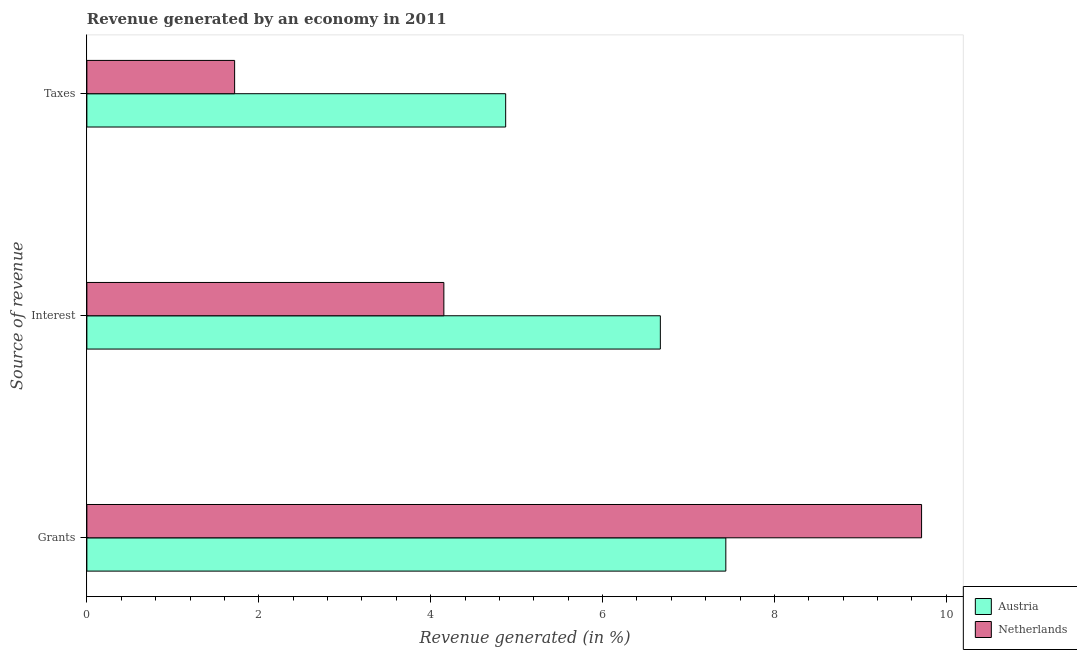Are the number of bars per tick equal to the number of legend labels?
Offer a very short reply. Yes. What is the label of the 1st group of bars from the top?
Your response must be concise. Taxes. What is the percentage of revenue generated by taxes in Austria?
Offer a very short reply. 4.87. Across all countries, what is the maximum percentage of revenue generated by taxes?
Offer a terse response. 4.87. Across all countries, what is the minimum percentage of revenue generated by taxes?
Provide a succinct answer. 1.72. In which country was the percentage of revenue generated by taxes minimum?
Provide a short and direct response. Netherlands. What is the total percentage of revenue generated by taxes in the graph?
Your answer should be compact. 6.59. What is the difference between the percentage of revenue generated by interest in Austria and that in Netherlands?
Provide a short and direct response. 2.52. What is the difference between the percentage of revenue generated by grants in Austria and the percentage of revenue generated by taxes in Netherlands?
Your answer should be very brief. 5.72. What is the average percentage of revenue generated by grants per country?
Give a very brief answer. 8.57. What is the difference between the percentage of revenue generated by grants and percentage of revenue generated by taxes in Netherlands?
Your answer should be very brief. 7.99. What is the ratio of the percentage of revenue generated by grants in Austria to that in Netherlands?
Your response must be concise. 0.77. What is the difference between the highest and the second highest percentage of revenue generated by interest?
Offer a terse response. 2.52. What is the difference between the highest and the lowest percentage of revenue generated by taxes?
Keep it short and to the point. 3.15. What does the 2nd bar from the bottom in Grants represents?
Your response must be concise. Netherlands. Is it the case that in every country, the sum of the percentage of revenue generated by grants and percentage of revenue generated by interest is greater than the percentage of revenue generated by taxes?
Make the answer very short. Yes. How many bars are there?
Give a very brief answer. 6. What is the difference between two consecutive major ticks on the X-axis?
Provide a succinct answer. 2. Are the values on the major ticks of X-axis written in scientific E-notation?
Your response must be concise. No. Does the graph contain any zero values?
Your response must be concise. No. Does the graph contain grids?
Keep it short and to the point. No. How are the legend labels stacked?
Ensure brevity in your answer.  Vertical. What is the title of the graph?
Offer a very short reply. Revenue generated by an economy in 2011. Does "St. Lucia" appear as one of the legend labels in the graph?
Make the answer very short. No. What is the label or title of the X-axis?
Your answer should be compact. Revenue generated (in %). What is the label or title of the Y-axis?
Your answer should be very brief. Source of revenue. What is the Revenue generated (in %) of Austria in Grants?
Offer a very short reply. 7.43. What is the Revenue generated (in %) in Netherlands in Grants?
Give a very brief answer. 9.71. What is the Revenue generated (in %) in Austria in Interest?
Provide a short and direct response. 6.67. What is the Revenue generated (in %) in Netherlands in Interest?
Your answer should be very brief. 4.15. What is the Revenue generated (in %) in Austria in Taxes?
Ensure brevity in your answer.  4.87. What is the Revenue generated (in %) of Netherlands in Taxes?
Offer a terse response. 1.72. Across all Source of revenue, what is the maximum Revenue generated (in %) of Austria?
Your answer should be very brief. 7.43. Across all Source of revenue, what is the maximum Revenue generated (in %) in Netherlands?
Make the answer very short. 9.71. Across all Source of revenue, what is the minimum Revenue generated (in %) of Austria?
Keep it short and to the point. 4.87. Across all Source of revenue, what is the minimum Revenue generated (in %) in Netherlands?
Make the answer very short. 1.72. What is the total Revenue generated (in %) in Austria in the graph?
Your answer should be compact. 18.98. What is the total Revenue generated (in %) of Netherlands in the graph?
Your answer should be compact. 15.59. What is the difference between the Revenue generated (in %) in Austria in Grants and that in Interest?
Provide a short and direct response. 0.76. What is the difference between the Revenue generated (in %) of Netherlands in Grants and that in Interest?
Make the answer very short. 5.56. What is the difference between the Revenue generated (in %) in Austria in Grants and that in Taxes?
Offer a very short reply. 2.56. What is the difference between the Revenue generated (in %) of Netherlands in Grants and that in Taxes?
Your answer should be very brief. 7.99. What is the difference between the Revenue generated (in %) in Austria in Interest and that in Taxes?
Give a very brief answer. 1.8. What is the difference between the Revenue generated (in %) of Netherlands in Interest and that in Taxes?
Provide a short and direct response. 2.43. What is the difference between the Revenue generated (in %) of Austria in Grants and the Revenue generated (in %) of Netherlands in Interest?
Offer a very short reply. 3.28. What is the difference between the Revenue generated (in %) in Austria in Grants and the Revenue generated (in %) in Netherlands in Taxes?
Your answer should be compact. 5.72. What is the difference between the Revenue generated (in %) in Austria in Interest and the Revenue generated (in %) in Netherlands in Taxes?
Offer a very short reply. 4.95. What is the average Revenue generated (in %) in Austria per Source of revenue?
Give a very brief answer. 6.33. What is the average Revenue generated (in %) in Netherlands per Source of revenue?
Offer a terse response. 5.2. What is the difference between the Revenue generated (in %) of Austria and Revenue generated (in %) of Netherlands in Grants?
Ensure brevity in your answer.  -2.28. What is the difference between the Revenue generated (in %) in Austria and Revenue generated (in %) in Netherlands in Interest?
Ensure brevity in your answer.  2.52. What is the difference between the Revenue generated (in %) in Austria and Revenue generated (in %) in Netherlands in Taxes?
Provide a succinct answer. 3.15. What is the ratio of the Revenue generated (in %) in Austria in Grants to that in Interest?
Offer a terse response. 1.11. What is the ratio of the Revenue generated (in %) in Netherlands in Grants to that in Interest?
Keep it short and to the point. 2.34. What is the ratio of the Revenue generated (in %) in Austria in Grants to that in Taxes?
Ensure brevity in your answer.  1.53. What is the ratio of the Revenue generated (in %) in Netherlands in Grants to that in Taxes?
Provide a short and direct response. 5.65. What is the ratio of the Revenue generated (in %) in Austria in Interest to that in Taxes?
Your answer should be very brief. 1.37. What is the ratio of the Revenue generated (in %) of Netherlands in Interest to that in Taxes?
Keep it short and to the point. 2.42. What is the difference between the highest and the second highest Revenue generated (in %) of Austria?
Provide a short and direct response. 0.76. What is the difference between the highest and the second highest Revenue generated (in %) in Netherlands?
Make the answer very short. 5.56. What is the difference between the highest and the lowest Revenue generated (in %) in Austria?
Give a very brief answer. 2.56. What is the difference between the highest and the lowest Revenue generated (in %) of Netherlands?
Offer a terse response. 7.99. 